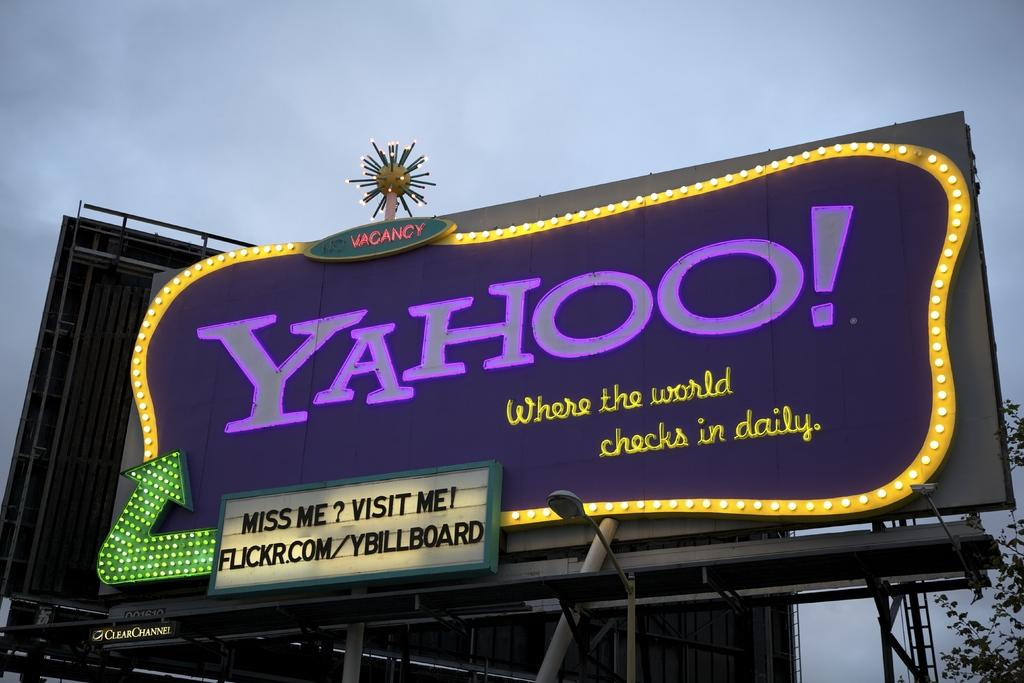<image>
Describe the image concisely. VINTAGE LOOKING YAHOO! SIGNBOARD WITH A SIGN SAYING "MISS ME? VISIT ME! FLICKR.COM/YBILLBOARD" 